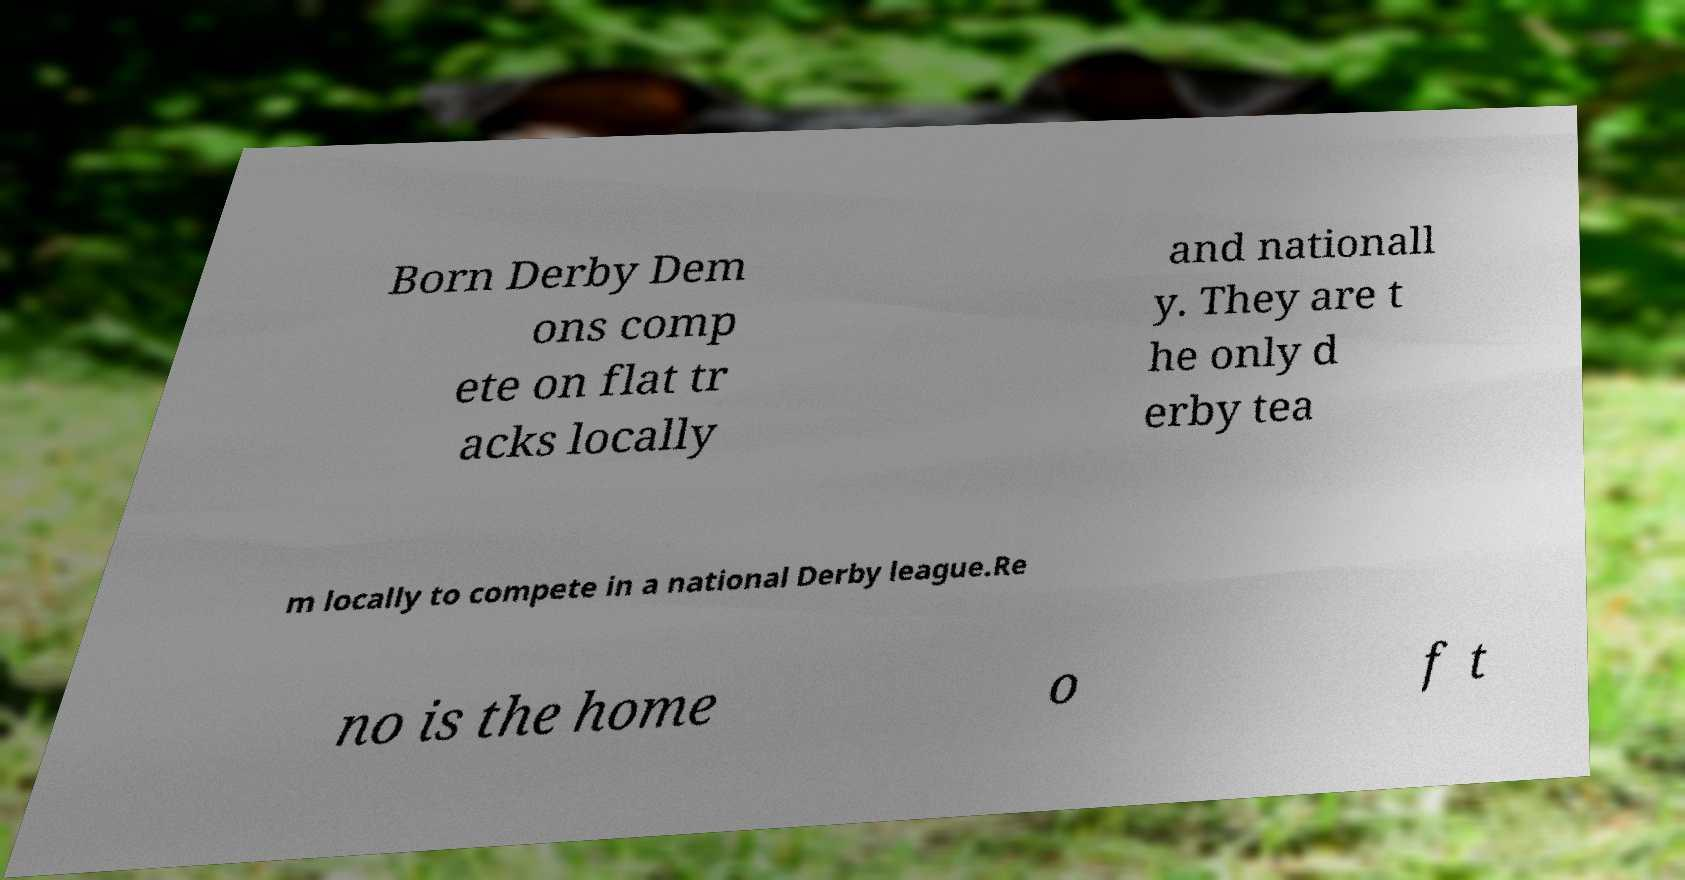Can you accurately transcribe the text from the provided image for me? Born Derby Dem ons comp ete on flat tr acks locally and nationall y. They are t he only d erby tea m locally to compete in a national Derby league.Re no is the home o f t 